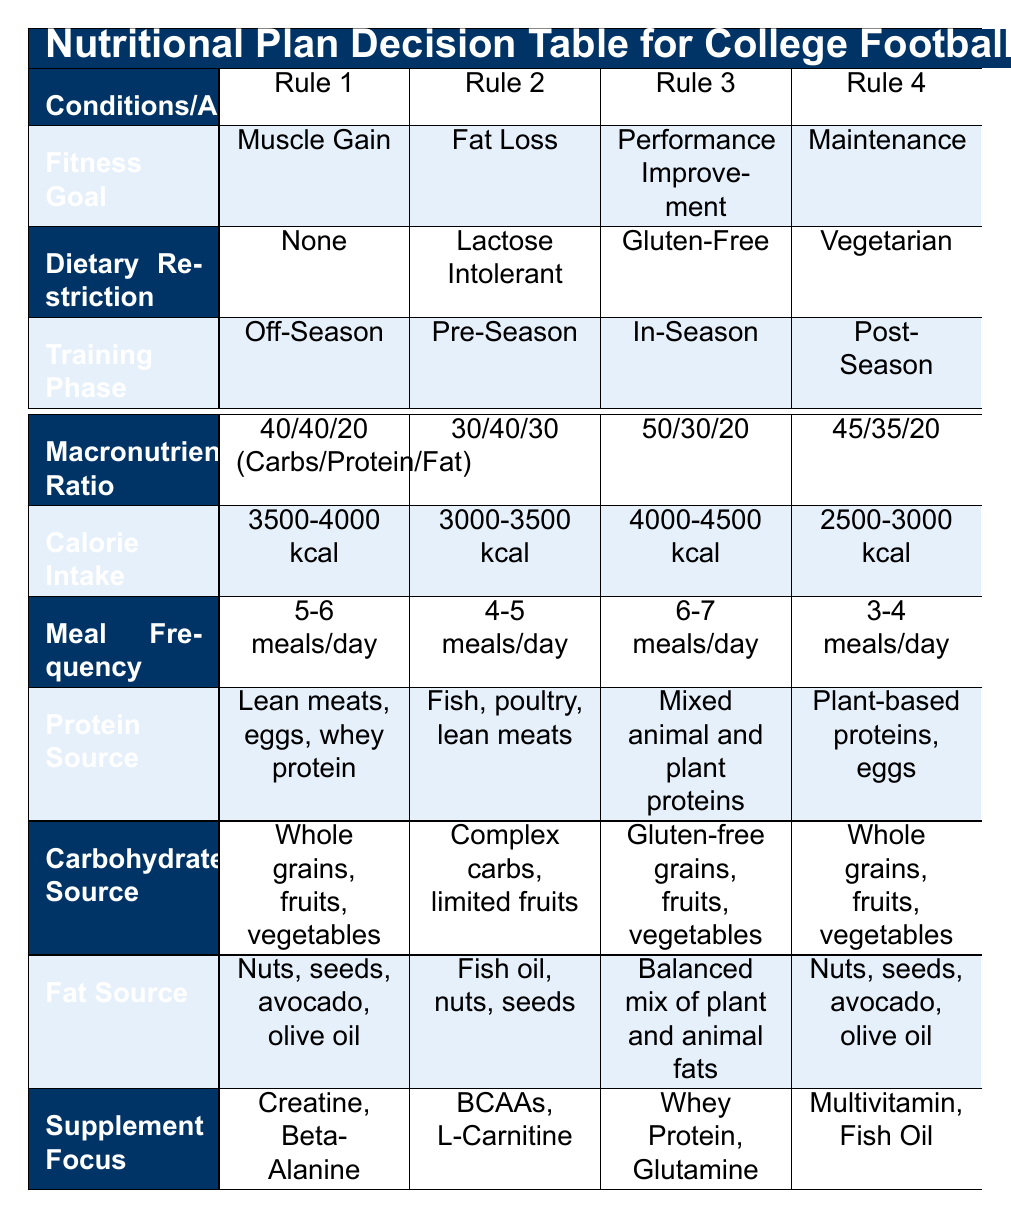What is the calorie intake for someone focused on muscle gain during the off-season? The table indicates that for the fitness goal of muscle gain with the dietary restriction of none and in the off-season, the calorie intake is specified as 3500-4000 kcal.
Answer: 3500-4000 kcal Which protein source is recommended for fat loss if lactose intolerant in the pre-season? According to the table, when the fitness goal is fat loss, dietary restriction is lactose intolerant, and the training phase is pre-season, the recommended protein source is fish, poultry, and lean meats.
Answer: Fish, poultry, lean meats True or False: The meal frequency for performance improvement in-season is 6-7 meals per day. The table shows that for the performance improvement goal in-season, the meal frequency is indeed listed as 6-7 meals per day, confirming the statement is true.
Answer: True What is the macronutrient ratio for someone who is vegetarian and in the post-season for maintenance? For the maintenance fitness goal with a vegetarian dietary restriction in the post-season, the table states that the macronutrient ratio is 45/35/20 (Carbs/Protein/Fat).
Answer: 45/35/20 (Carbs/Protein/Fat) If someone with a gluten-free dietary restriction is training in-season for performance improvement, what are the recommended fat sources? In the case of being gluten-free and focusing on performance improvement during the in-season, the table lists the recommended fat sources as a balanced mix of plant and animal fats.
Answer: Balanced mix of plant and animal fats What would be the average calorie intake among the provided rules in the table? To find the average calorie intake, we consider the specified ranges: (3500-4000 + 3000-3500 + 4000-4500 + 2500-3000) / 4. The midpoint values are approximately 3750, 3250, 4250, and 2750, giving an average of (3750 + 3250 + 4250 + 2750) / 4 = 3500.
Answer: 3500 How many meal frequencies are specified across the different plans? The table lists four different meal frequency options: 5-6 meals/day, 4-5 meals/day, 6-7 meals/day, and 3-4 meals/day. Therefore, there are a total of 4 meal frequency specifications given.
Answer: 4 